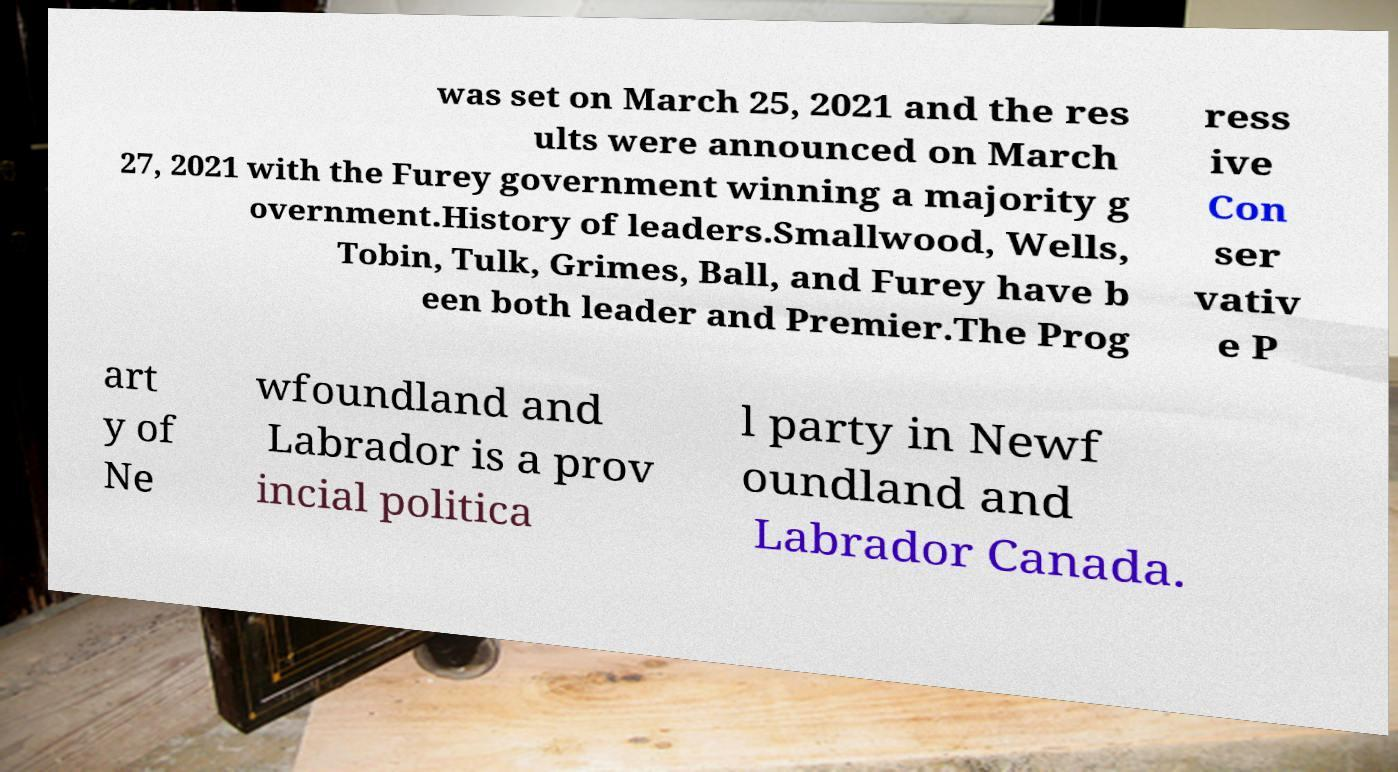Please identify and transcribe the text found in this image. was set on March 25, 2021 and the res ults were announced on March 27, 2021 with the Furey government winning a majority g overnment.History of leaders.Smallwood, Wells, Tobin, Tulk, Grimes, Ball, and Furey have b een both leader and Premier.The Prog ress ive Con ser vativ e P art y of Ne wfoundland and Labrador is a prov incial politica l party in Newf oundland and Labrador Canada. 